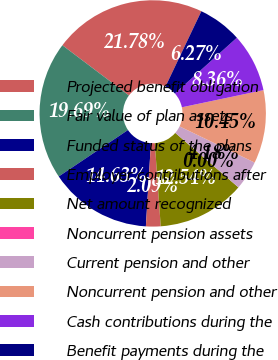<chart> <loc_0><loc_0><loc_500><loc_500><pie_chart><fcel>Projected benefit obligation<fcel>Fair value of plan assets<fcel>Funded status of the plans<fcel>Employer contributions after<fcel>Net amount recognized<fcel>Noncurrent pension assets<fcel>Current pension and other<fcel>Noncurrent pension and other<fcel>Cash contributions during the<fcel>Benefit payments during the<nl><fcel>21.78%<fcel>19.69%<fcel>14.63%<fcel>2.09%<fcel>12.54%<fcel>0.0%<fcel>4.18%<fcel>10.45%<fcel>8.36%<fcel>6.27%<nl></chart> 